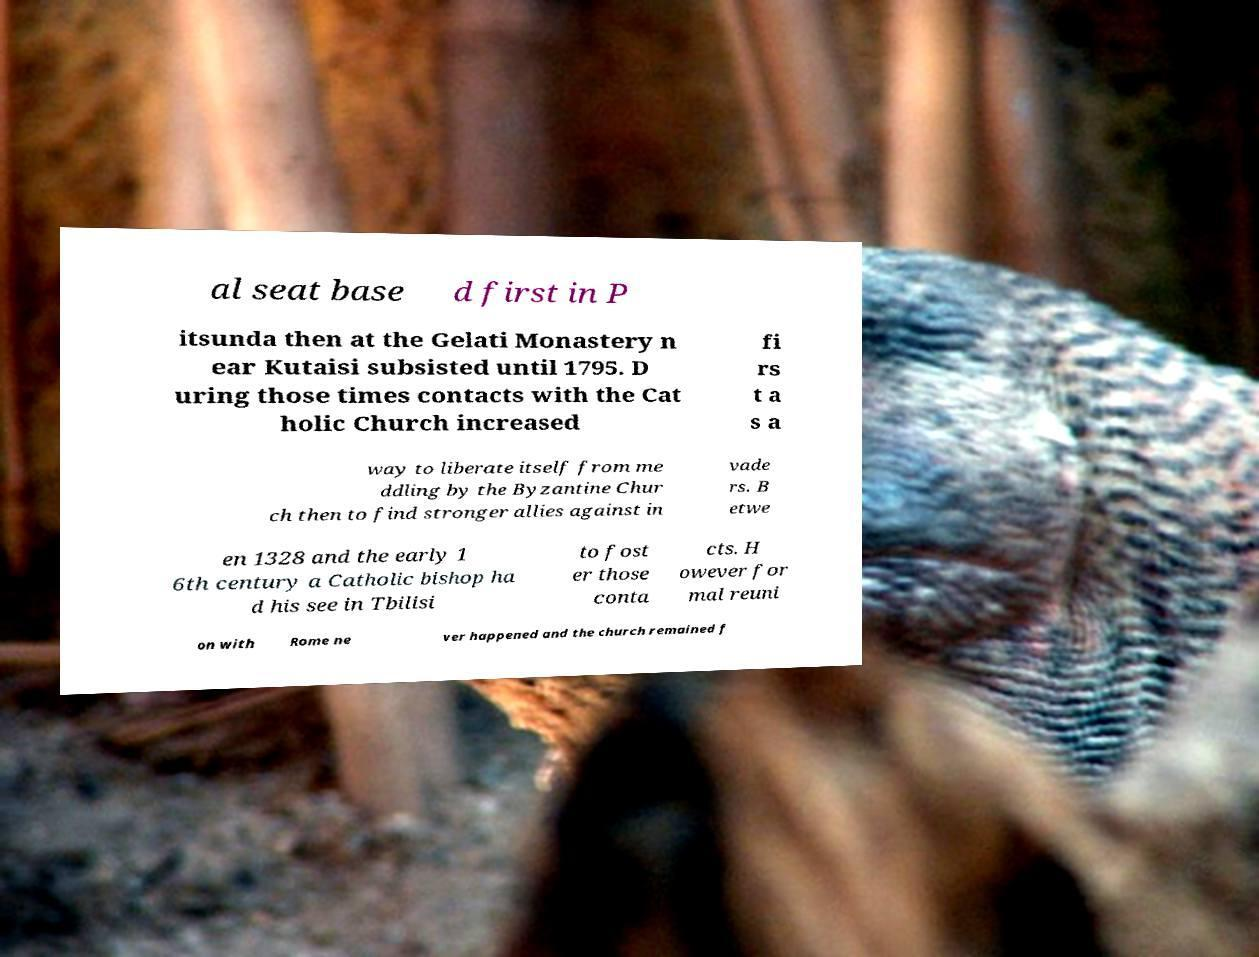Could you assist in decoding the text presented in this image and type it out clearly? al seat base d first in P itsunda then at the Gelati Monastery n ear Kutaisi subsisted until 1795. D uring those times contacts with the Cat holic Church increased fi rs t a s a way to liberate itself from me ddling by the Byzantine Chur ch then to find stronger allies against in vade rs. B etwe en 1328 and the early 1 6th century a Catholic bishop ha d his see in Tbilisi to fost er those conta cts. H owever for mal reuni on with Rome ne ver happened and the church remained f 